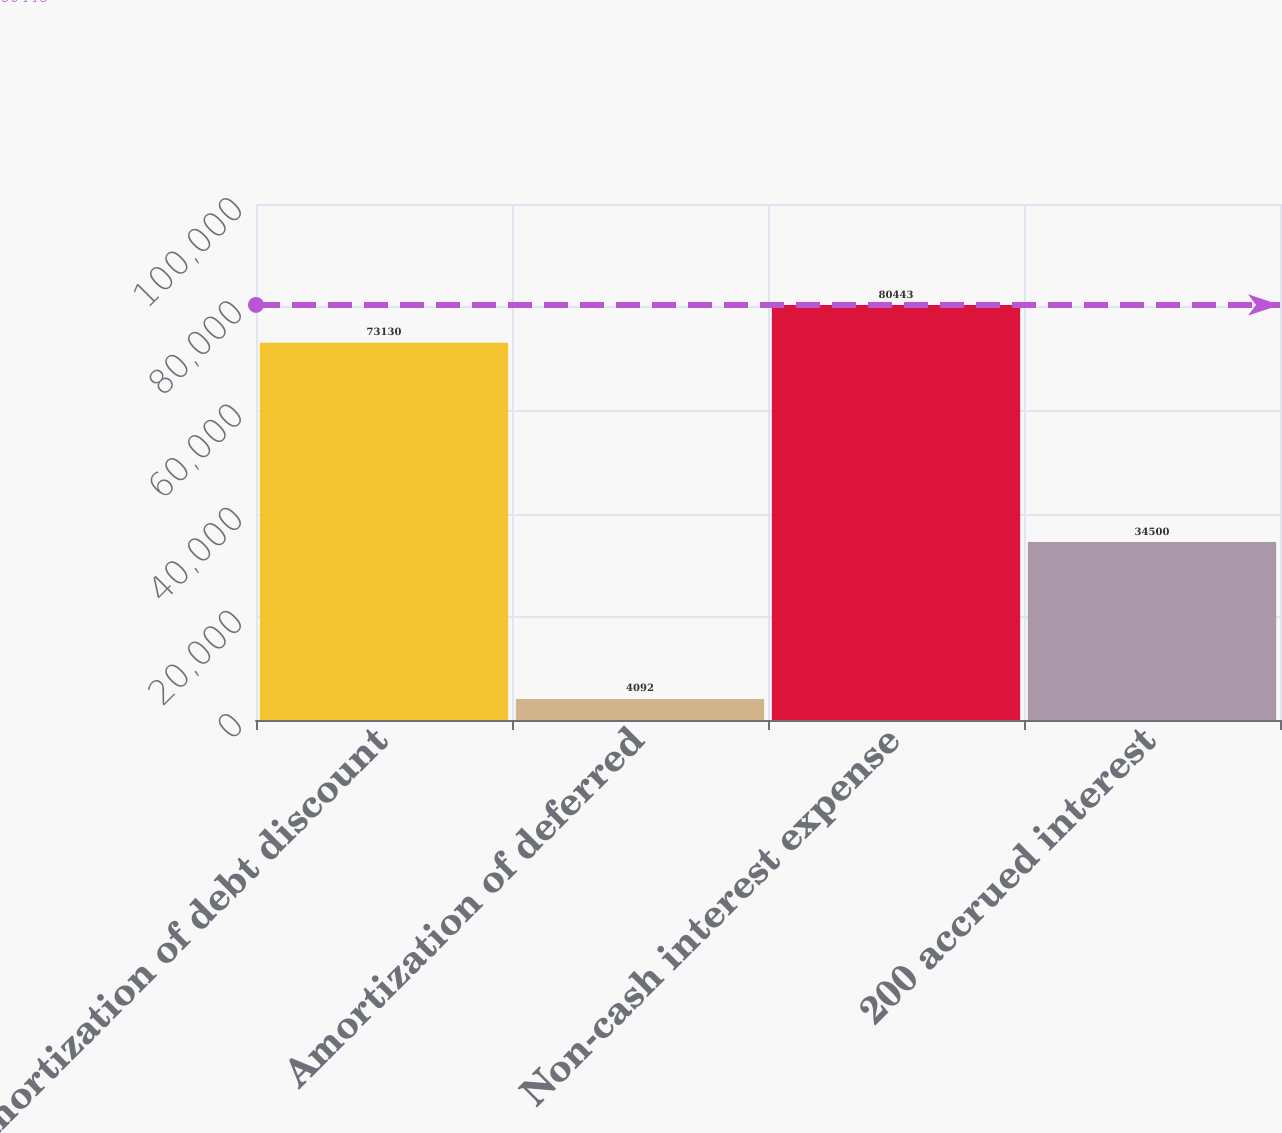<chart> <loc_0><loc_0><loc_500><loc_500><bar_chart><fcel>Amortization of debt discount<fcel>Amortization of deferred<fcel>Non-cash interest expense<fcel>200 accrued interest<nl><fcel>73130<fcel>4092<fcel>80443<fcel>34500<nl></chart> 